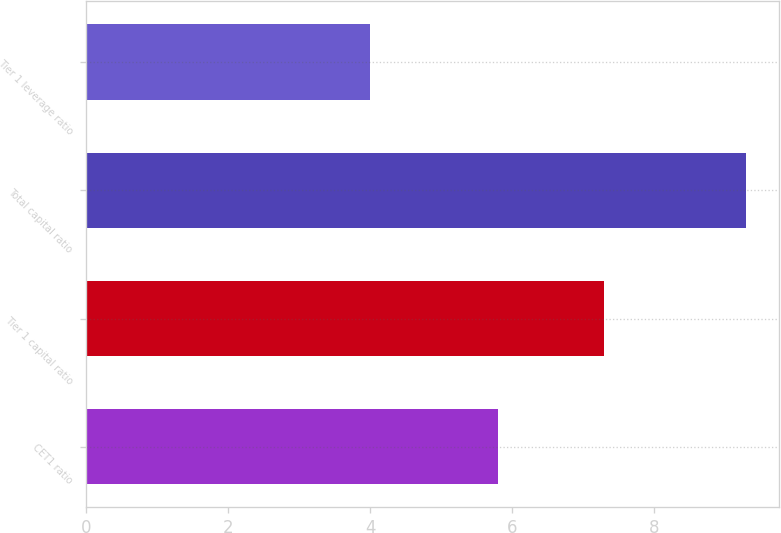Convert chart to OTSL. <chart><loc_0><loc_0><loc_500><loc_500><bar_chart><fcel>CET1 ratio<fcel>Tier 1 capital ratio<fcel>Total capital ratio<fcel>Tier 1 leverage ratio<nl><fcel>5.8<fcel>7.3<fcel>9.3<fcel>4<nl></chart> 